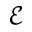<formula> <loc_0><loc_0><loc_500><loc_500>\mathcal { E }</formula> 